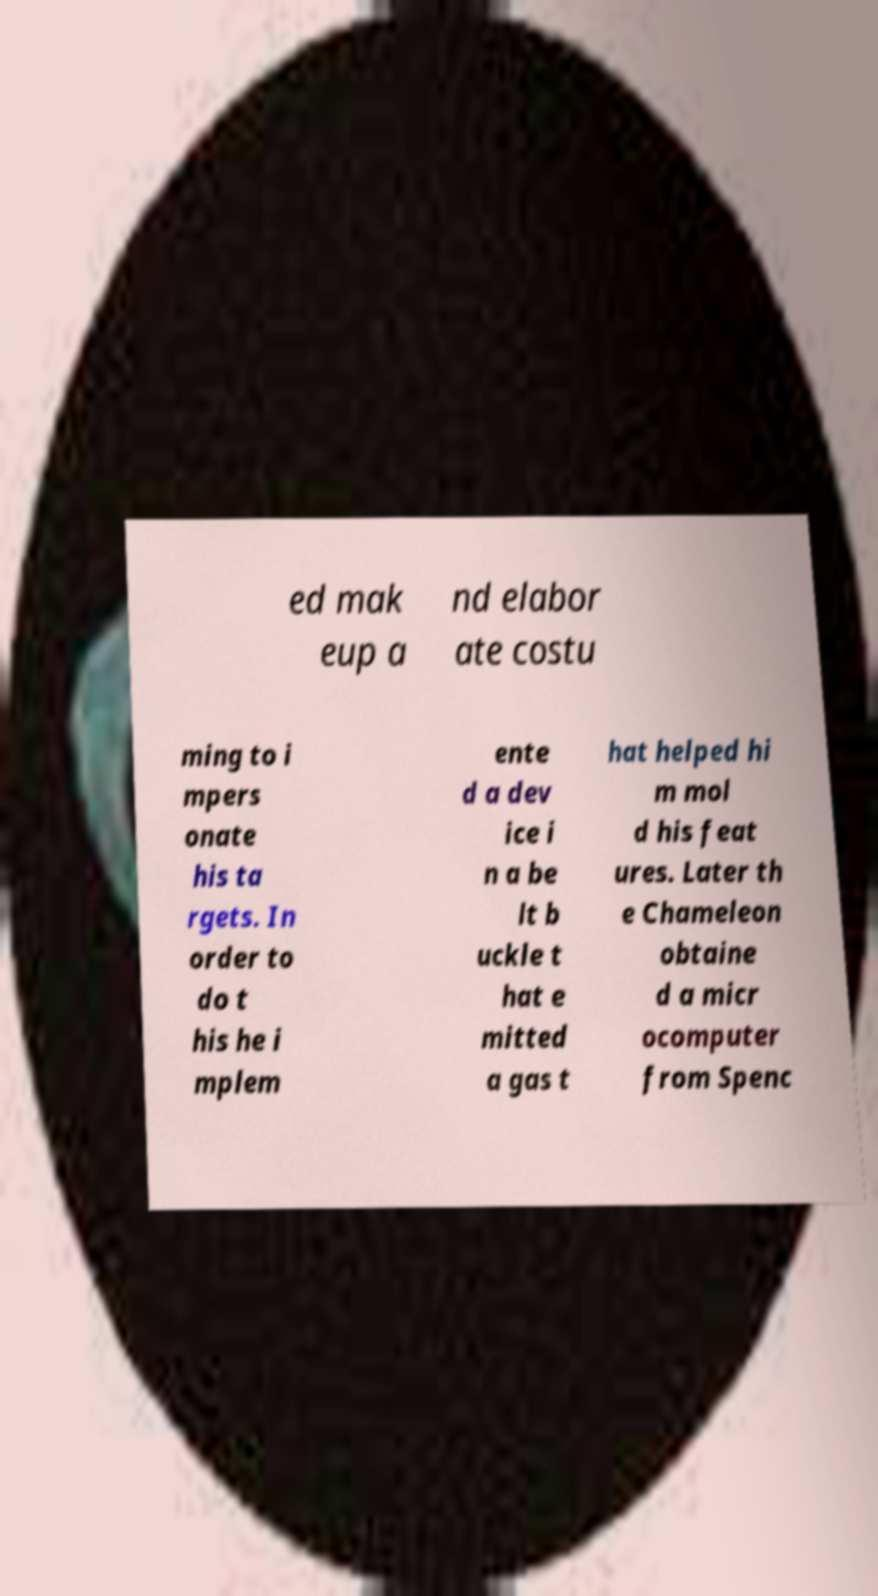Can you read and provide the text displayed in the image?This photo seems to have some interesting text. Can you extract and type it out for me? ed mak eup a nd elabor ate costu ming to i mpers onate his ta rgets. In order to do t his he i mplem ente d a dev ice i n a be lt b uckle t hat e mitted a gas t hat helped hi m mol d his feat ures. Later th e Chameleon obtaine d a micr ocomputer from Spenc 